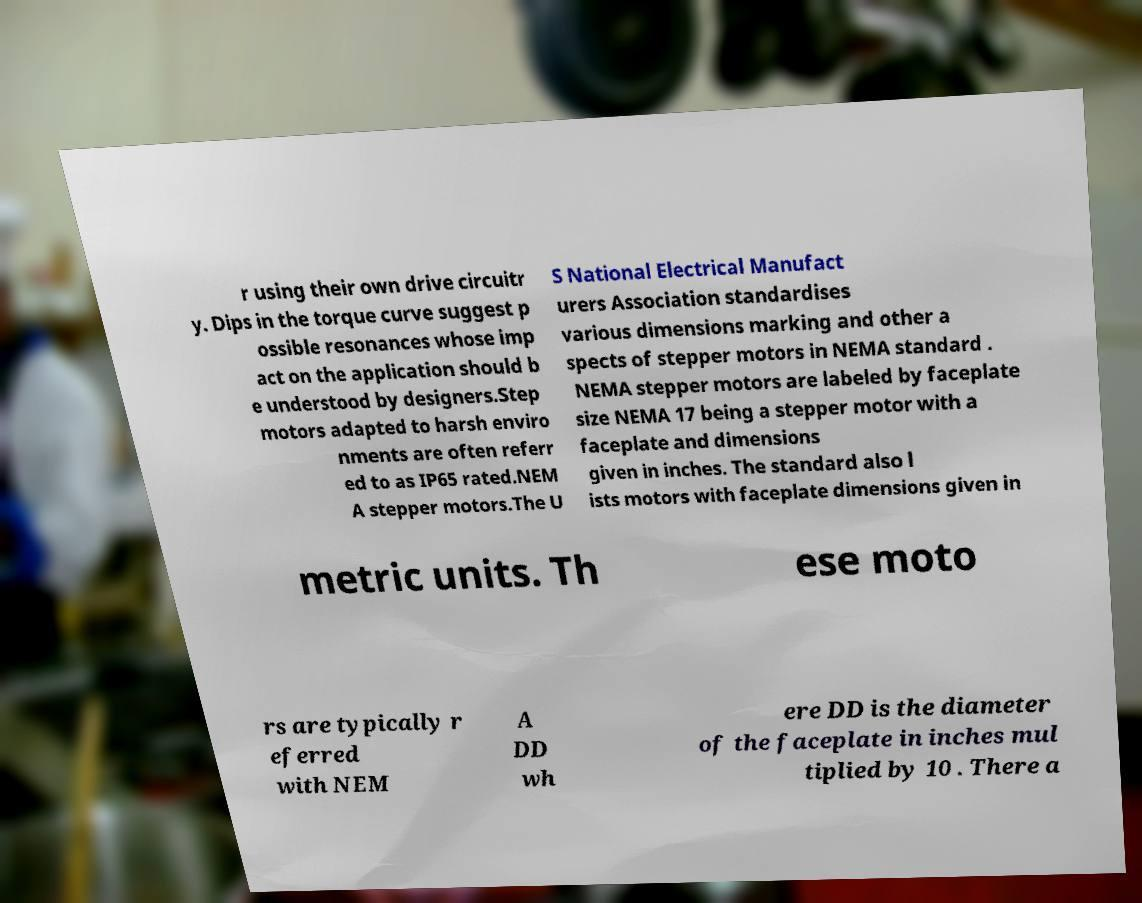Can you read and provide the text displayed in the image?This photo seems to have some interesting text. Can you extract and type it out for me? r using their own drive circuitr y. Dips in the torque curve suggest p ossible resonances whose imp act on the application should b e understood by designers.Step motors adapted to harsh enviro nments are often referr ed to as IP65 rated.NEM A stepper motors.The U S National Electrical Manufact urers Association standardises various dimensions marking and other a spects of stepper motors in NEMA standard . NEMA stepper motors are labeled by faceplate size NEMA 17 being a stepper motor with a faceplate and dimensions given in inches. The standard also l ists motors with faceplate dimensions given in metric units. Th ese moto rs are typically r eferred with NEM A DD wh ere DD is the diameter of the faceplate in inches mul tiplied by 10 . There a 